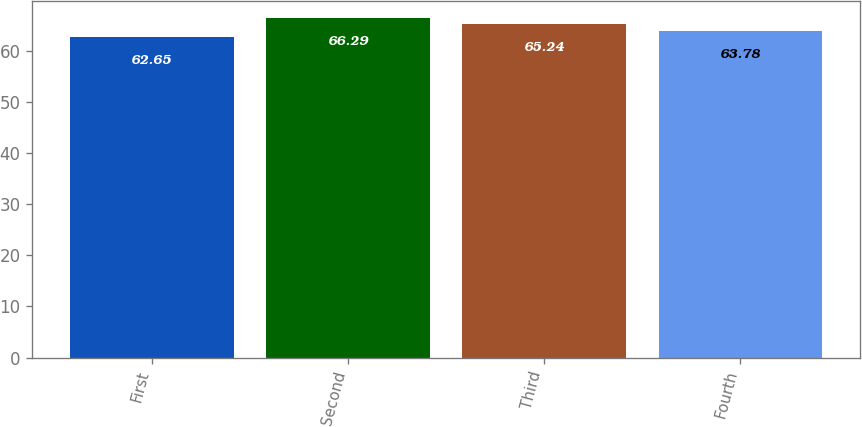Convert chart. <chart><loc_0><loc_0><loc_500><loc_500><bar_chart><fcel>First<fcel>Second<fcel>Third<fcel>Fourth<nl><fcel>62.65<fcel>66.29<fcel>65.24<fcel>63.78<nl></chart> 